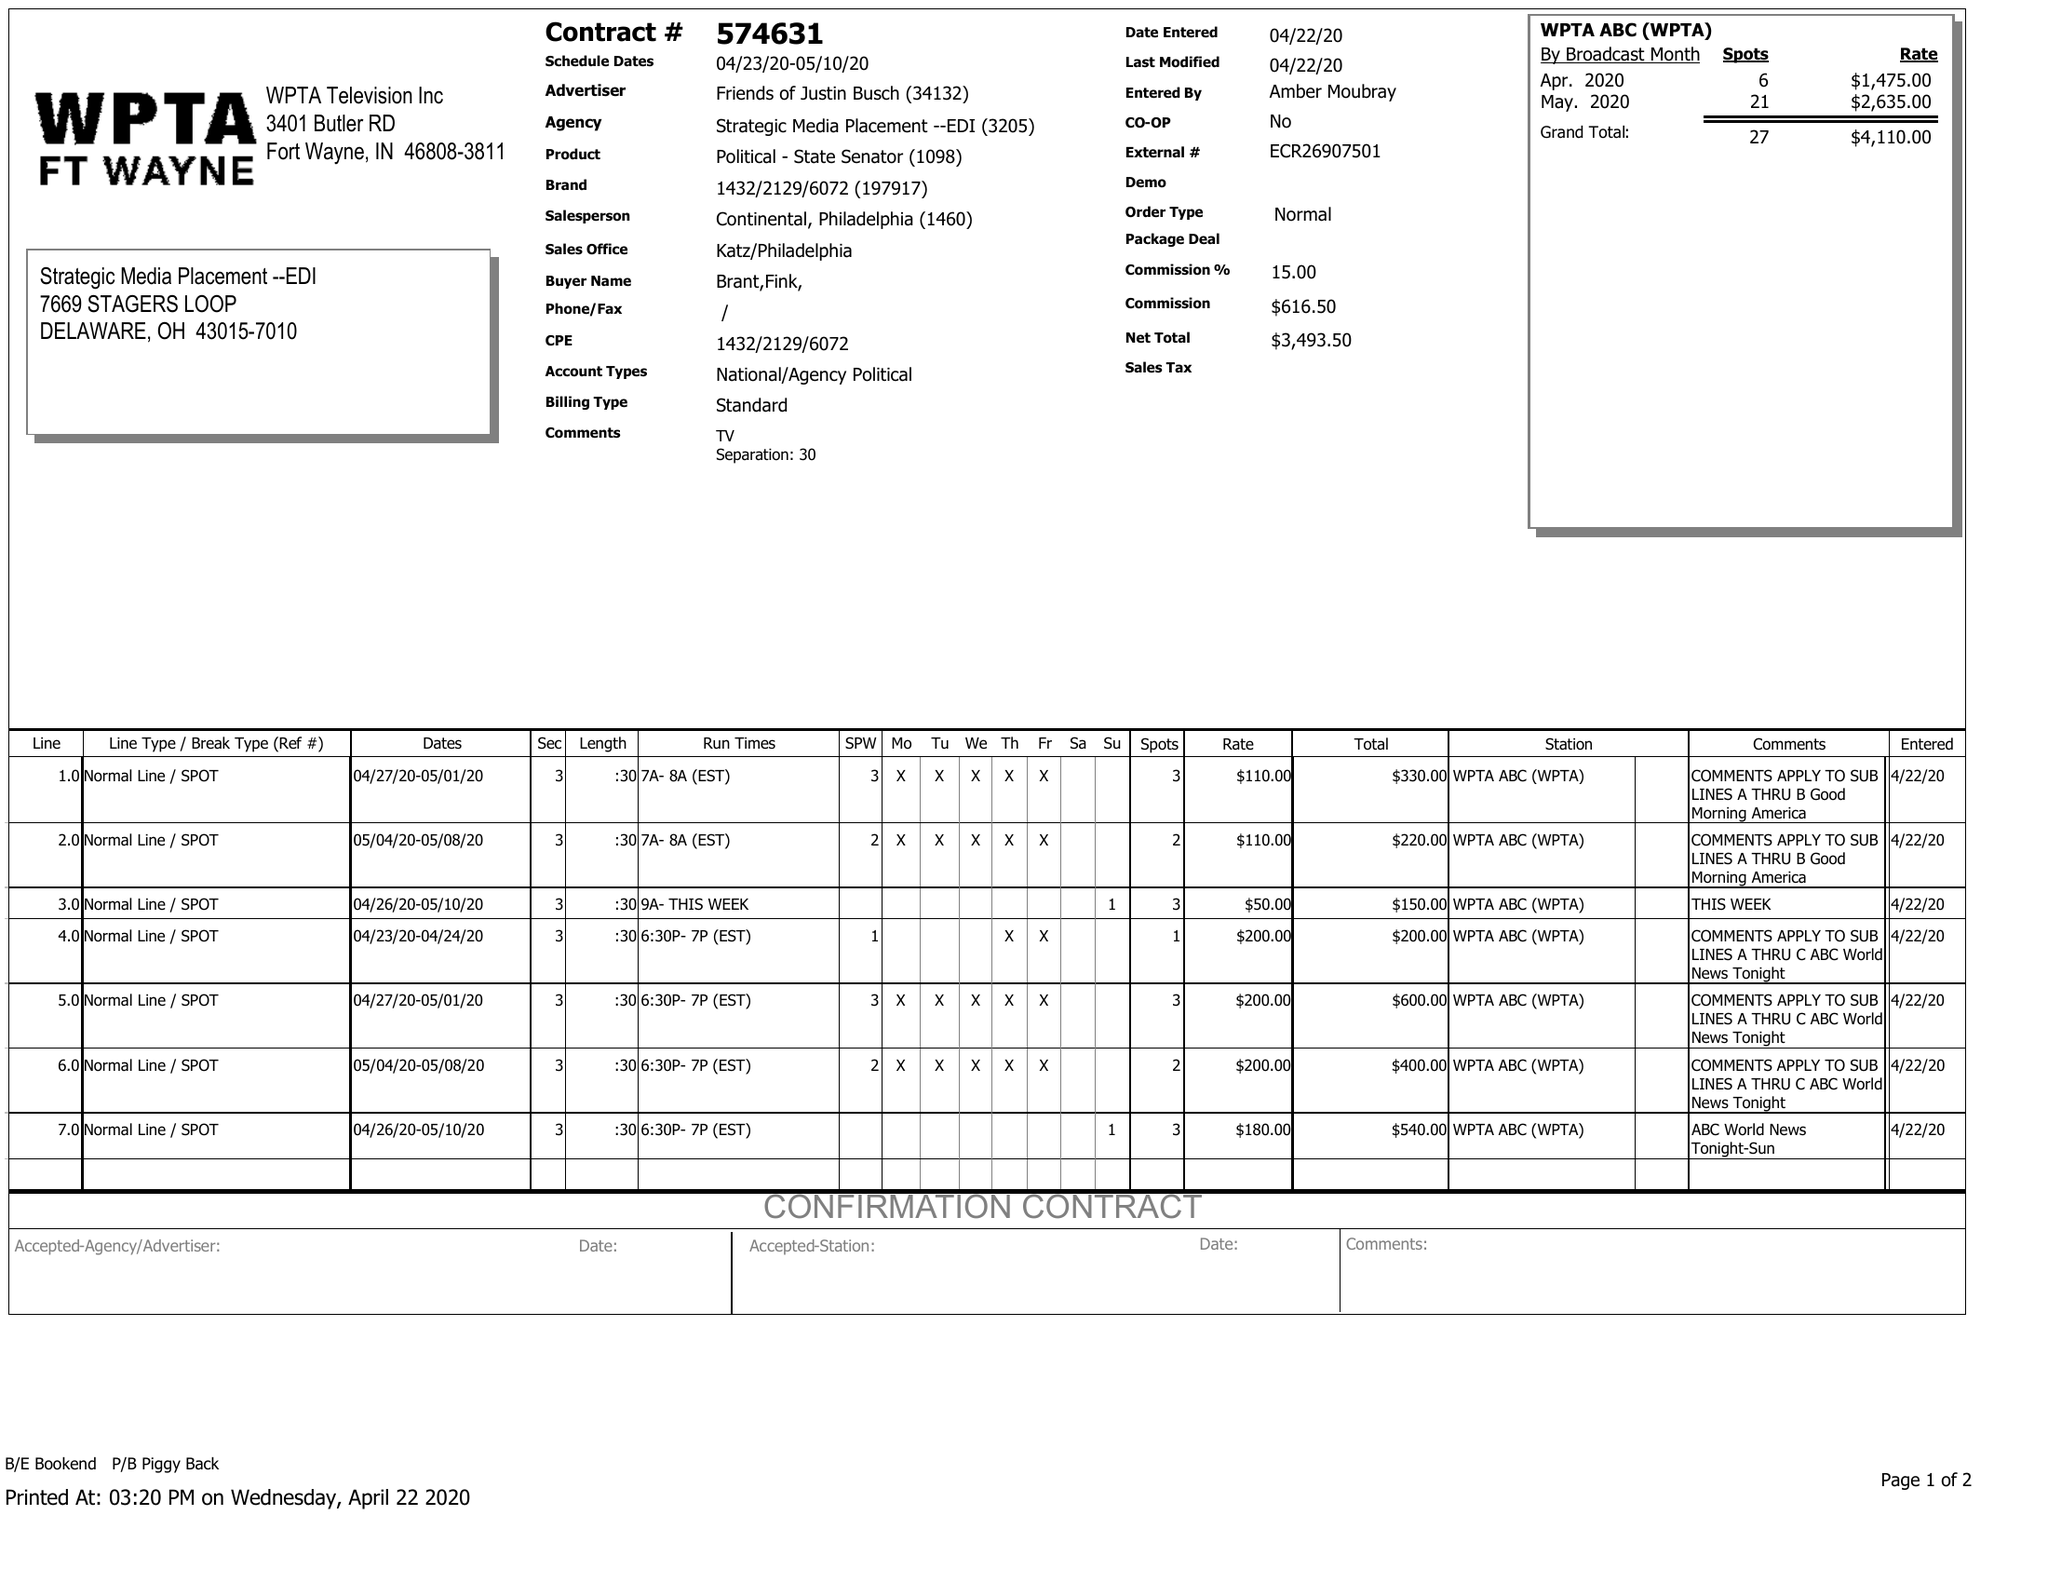What is the value for the flight_to?
Answer the question using a single word or phrase. 05/10/20 